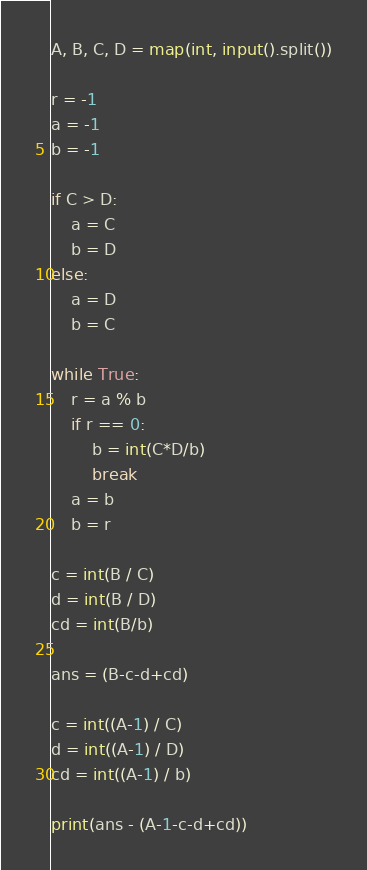<code> <loc_0><loc_0><loc_500><loc_500><_Python_>A, B, C, D = map(int, input().split())

r = -1
a = -1
b = -1

if C > D:
    a = C
    b = D
else:
    a = D
    b = C

while True:
    r = a % b
    if r == 0:
        b = int(C*D/b)
        break
    a = b
    b = r

c = int(B / C)
d = int(B / D)
cd = int(B/b)

ans = (B-c-d+cd)

c = int((A-1) / C)
d = int((A-1) / D)
cd = int((A-1) / b)

print(ans - (A-1-c-d+cd))
</code> 